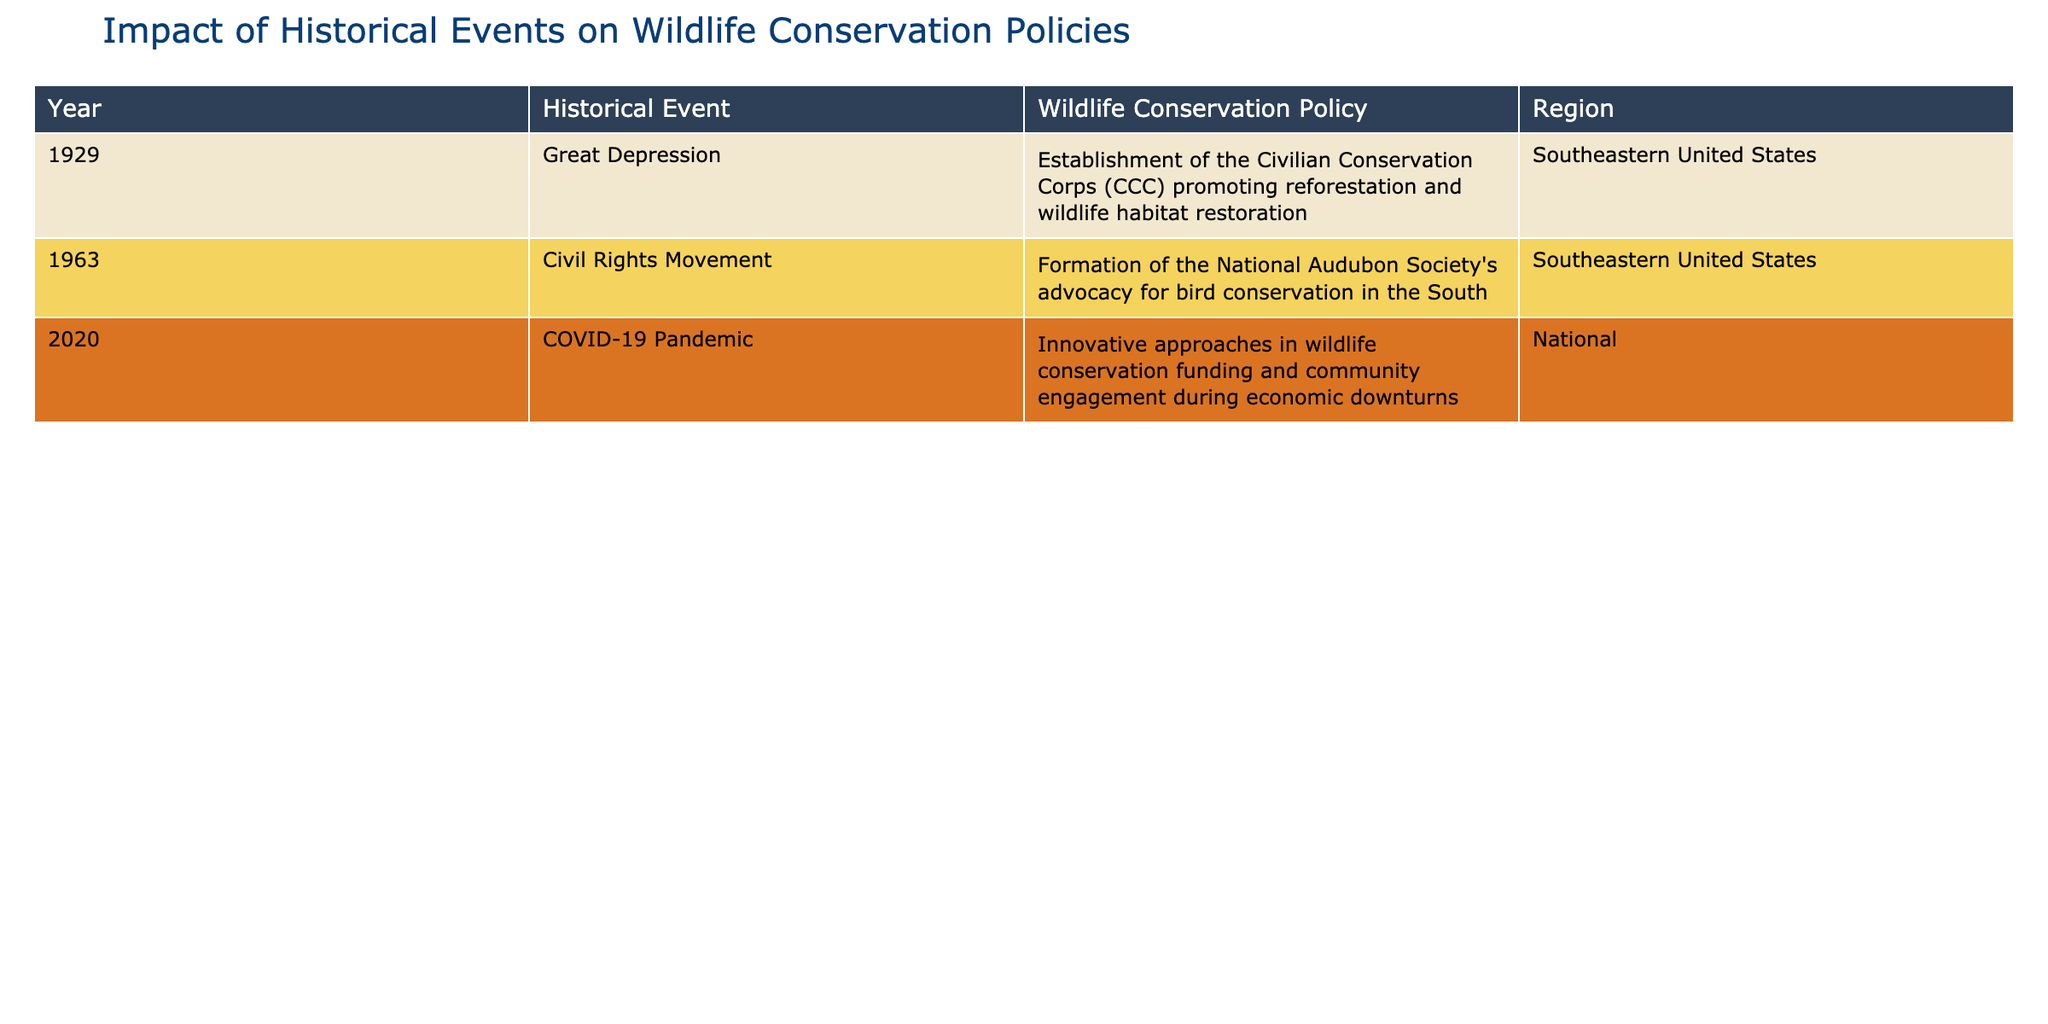What wildlife conservation policy was established in 1929? The table indicates that in 1929, the historical event was the Great Depression, and the corresponding wildlife conservation policy was the establishment of the Civilian Conservation Corps promoting reforestation and wildlife habitat restoration.
Answer: Establishment of the Civilian Conservation Corps What region was affected by the Civil Rights Movement's impact on wildlife conservation? According to the table, the Civil Rights Movement in 1963 specifically influenced the Southeastern United States, as indicated in the region column.
Answer: Southeastern United States How many historical events lead to wildlife conservation policies were documented in the table? The table lists three historical events (Great Depression, Civil Rights Movement, COVID-19 Pandemic) that resulted in wildlife conservation policies, thus the count is three.
Answer: Three Did the policy established during the COVID-19 Pandemic focus on regional issues only? The table shows that the wildlife conservation policy during the COVID-19 Pandemic was nationally focused, suggesting that it was not limited to a specific region. Therefore, the answer is no.
Answer: No What is the difference in focus between wildlife conservation policies from 1929 and 2020? The 1929 policy focused on habitat restoration and reforestation, while the 2020 policy emphasized community engagement and innovative funding during economic difficulties. This indicates a shift from purely ecological work to a broader community-oriented approach.
Answer: Shift to community engagement and funding What types of wildlife conservation policies emerged in the Southeastern United States over the decades represented in the table? The table shows that the Southeastern United States had a policy focused on habitat restoration in 1929 and advocacy for bird conservation in 1963. This indicates a trend of developing policies that address both habitat and species-specific conservation over the years.
Answer: Habitat restoration and bird conservation advocacy Which historical event corresponds to the most recent policy mentioned in the table? The most recent policy refers to adaptations in wildlife conservation funding during the economic impact of the COVID-19 Pandemic, which is the latest historical event noted in the table.
Answer: COVID-19 Pandemic What is the overall trend in wildlife conservation policies based on historical events from the table? The historical events show an evolution from economic-focused conservation efforts in 1929 to advocacy movements in 1963, culminating in innovative funding strategies due to a global pandemic. This suggests an increasing awareness of broader social contexts within wildlife conservation.
Answer: Evolution from economic to community and advocacy focus 